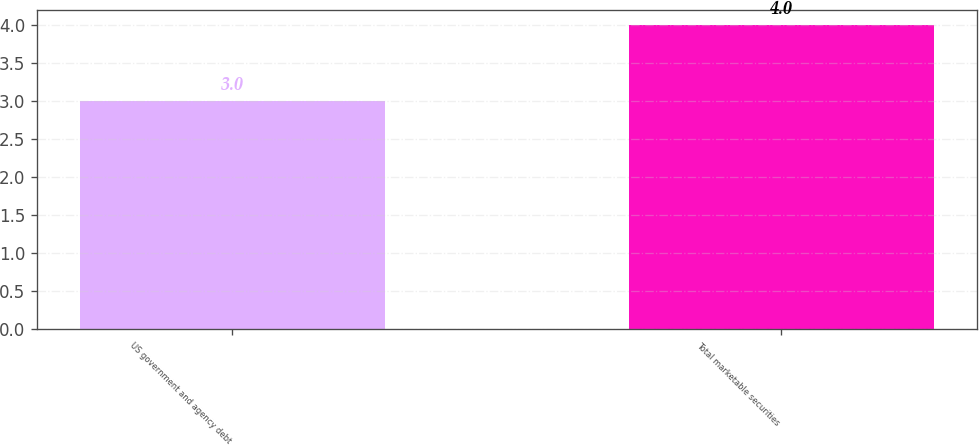Convert chart to OTSL. <chart><loc_0><loc_0><loc_500><loc_500><bar_chart><fcel>US government and agency debt<fcel>Total marketable securities<nl><fcel>3<fcel>4<nl></chart> 